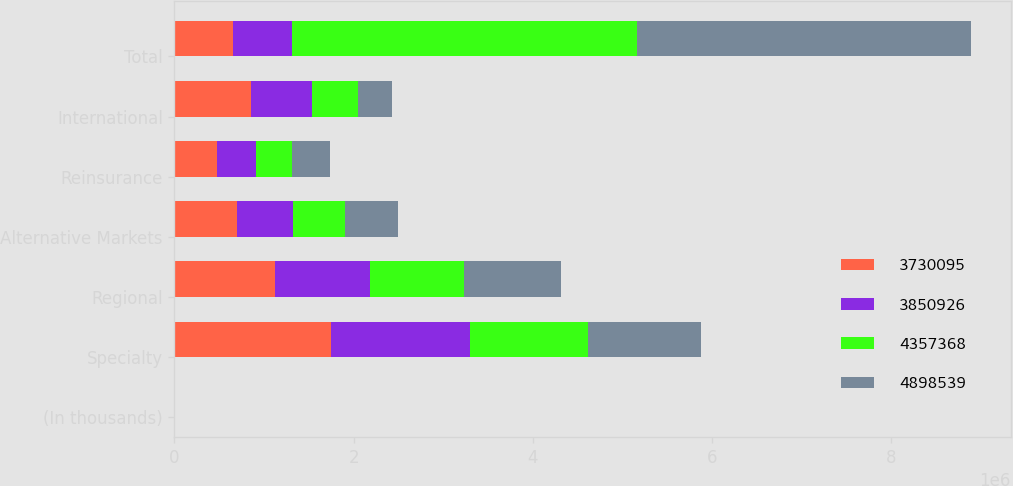Convert chart. <chart><loc_0><loc_0><loc_500><loc_500><stacked_bar_chart><ecel><fcel>(In thousands)<fcel>Specialty<fcel>Regional<fcel>Alternative Markets<fcel>Reinsurance<fcel>International<fcel>Total<nl><fcel>3.7301e+06<fcel>2012<fcel>1.74769e+06<fcel>1.11927e+06<fcel>702922<fcel>477252<fcel>851404<fcel>654008<nl><fcel>3.85093e+06<fcel>2011<fcel>1.55452e+06<fcel>1.06451e+06<fcel>619097<fcel>430329<fcel>688919<fcel>654008<nl><fcel>4.35737e+06<fcel>2010<fcel>1.31183e+06<fcel>1.04435e+06<fcel>582045<fcel>401239<fcel>511464<fcel>3.85093e+06<nl><fcel>4.89854e+06<fcel>2009<fcel>1.26045e+06<fcel>1.0811e+06<fcel>589637<fcel>423425<fcel>375482<fcel>3.7301e+06<nl></chart> 